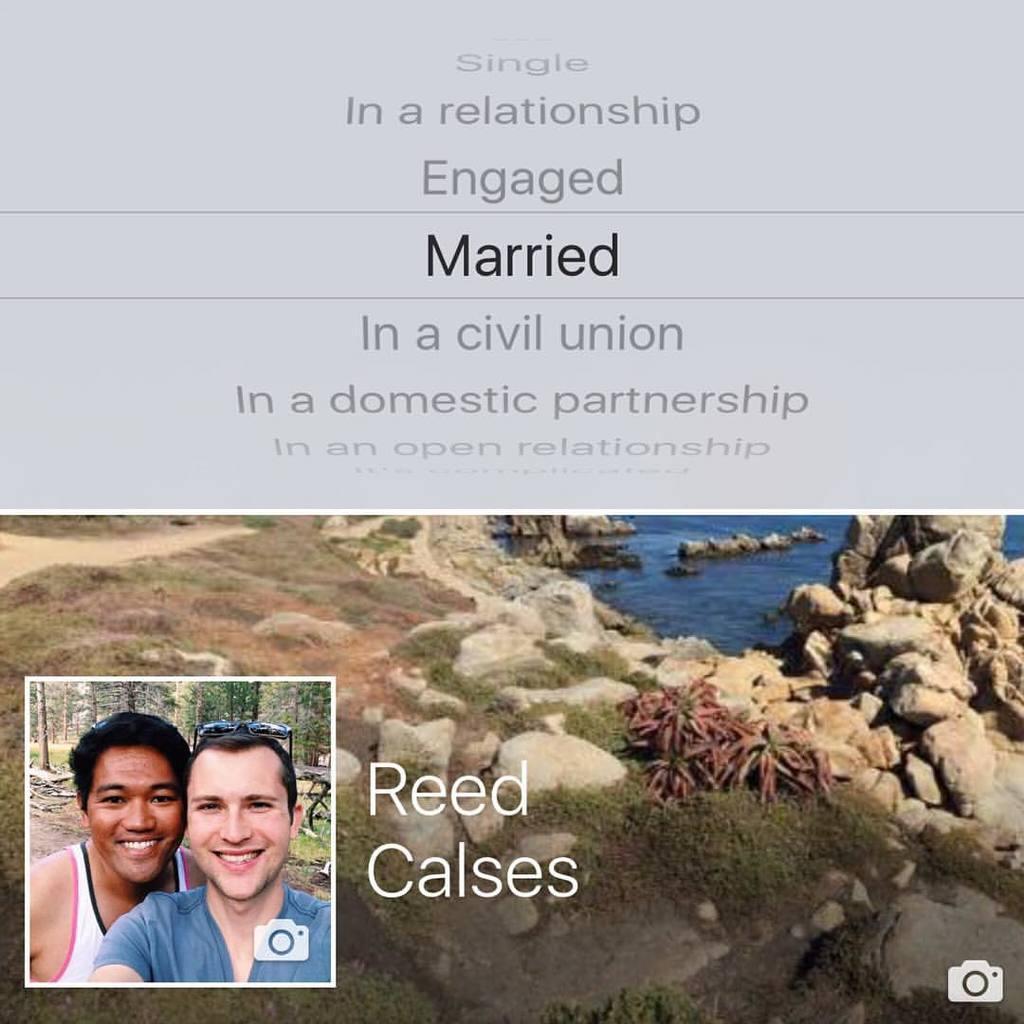Describe this image in one or two sentences. In this image there are two persons and there are rocks and a sea. 